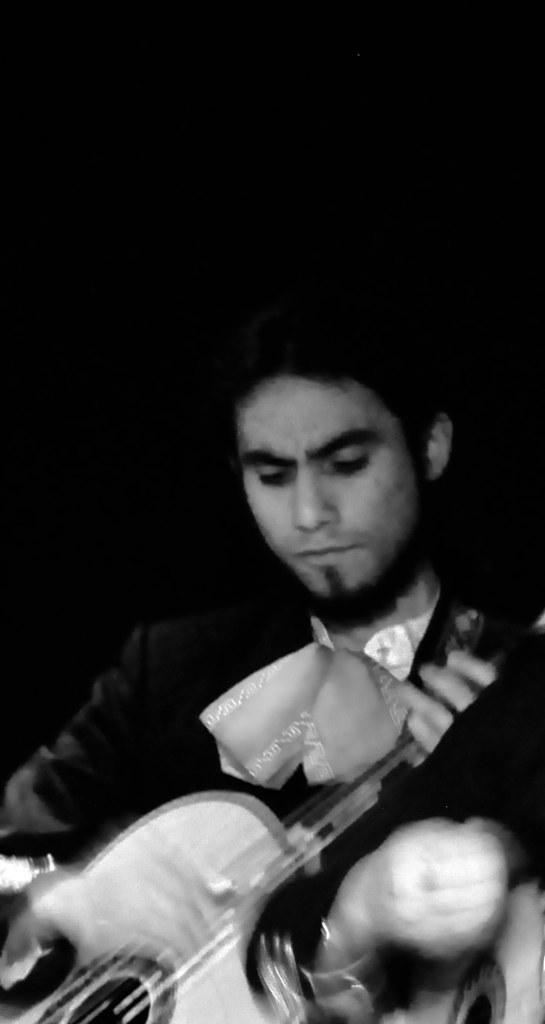What is the main subject of the image? The main subject of the image is a man. What is the man holding in the image? The man is holding a musical instrument in the image. What is the man doing with the musical instrument? The man is playing the musical instrument in the image. What type of house is visible in the background of the image? There is no house visible in the background of the image; it only features a man playing a musical instrument. Can you tell me how many teeth the man has in the image? The image does not show the man's teeth, so it is not possible to determine the number of teeth he has. 